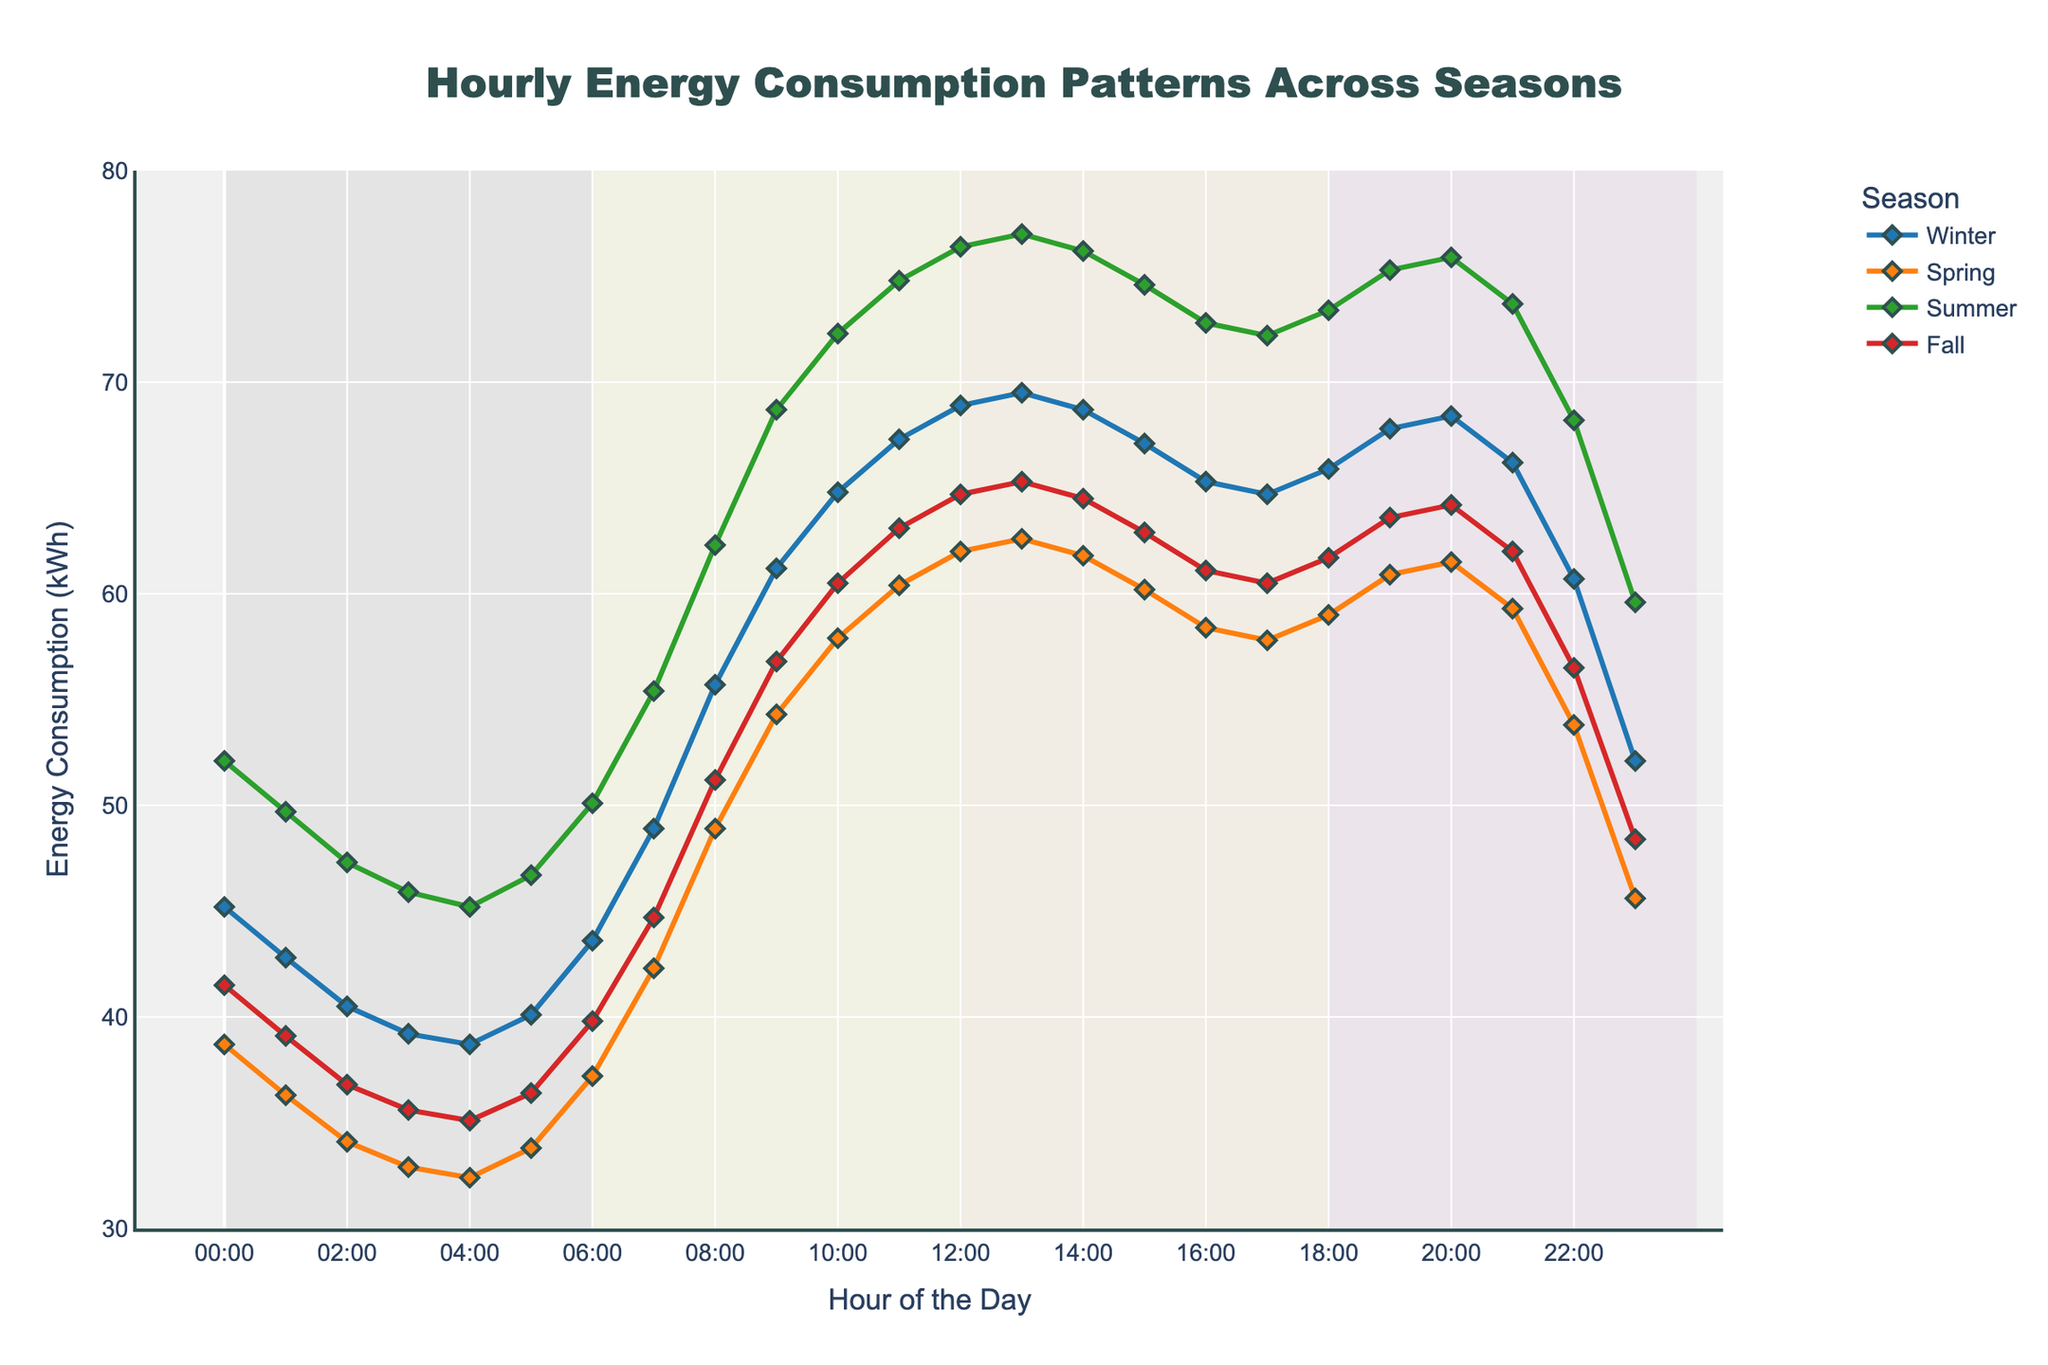What time of day does Summer have its highest energy consumption? Scan through the data points for Summer to identify the highest value. The highest energy consumption for Summer is 77.0 kWh at 13:00 (1 PM).
Answer: 13:00 (1 PM) How does Winter’s energy consumption at 09:00 compare to Spring’s energy consumption at the same time? Look at the data from Winter and Spring columns at the 09:00 mark. Winter’s energy consumption is 61.2 kWh and Spring’s is 54.3 kWh. Thus, Winter's energy consumption is higher.
Answer: Winter's is higher Which season has the lowest energy consumption, and at what hour does it occur? Find the minimum value across all seasons. The lowest energy consumption across all seasons is 32.4 kWh in Spring at 04:00.
Answer: Spring at 04:00 During which period of the day does the energy consumption in Fall consistently rise? Check the data for Fall from the "Night" period (00:00-06:00) through the "Morning" period (06:00-12:00). The "Morning" period shows a consistent rise.
Answer: Morning Calculate the average energy consumption for Winter between 06:00 and 18:00. Sum the data points for Winter between these hours and divide by the number of points (12). Sum = 43.6 + 48.9 + 55.7 + 61.2 + 64.8 + 67.3 + 68.9 + 69.5 + 68.7 + 67.1 + 65.3 + 64.7 = 745.7. Average = 745.7 / 12 = 62.14 kWh.
Answer: 62.14 kWh What is the energy consumption trend in Summer during the "Afternoon" period? Identify the data points from 12:00 to 18:00 for Summer. The consumption starts at 76.4 kWh, peaks at 77.0 kWh at 13:00, and then generally decreases to 73.4 kWh by 18:00, indicating a slight downward trend after the peak.
Answer: Slight downward trend Which season shows the least variation in energy consumption over the 24-hour period? Assess the range (difference between the highest and lowest values) for each season. Winter (69.5-38.7 = 30.8) has the least variation compared to Spring (62.6-32.4=30.2), Summer (77.0-45.2 = 31.8), and Fall (65.3-35.1 = 30.2).
Answer: Winter At what hours do the energy consumption patterns of Winter and Fall intersect? Look for hours where the energy consumption values of Winter and Fall are the same. Energy consumption for Winter and Fall are equal at 18:00 with both at 65.9 kWh.
Answer: 18:00 What is the difference in average energy consumption between Winter and Summer during the "Morning" period (06:00-12:00)? First, calculate the average values for Winter and Summer from 06:00 to 12:00. Winter: (43.6+48.9+55.7+61.2+64.8+67.3)/6 = 56.92 kWh. Summer: (50.1+55.4+62.3+68.7+72.3+74.8)/6 = 63.93 kWh. The difference is 63.93 - 56.92 = 7.01 kWh.
Answer: 7.01 kWh 